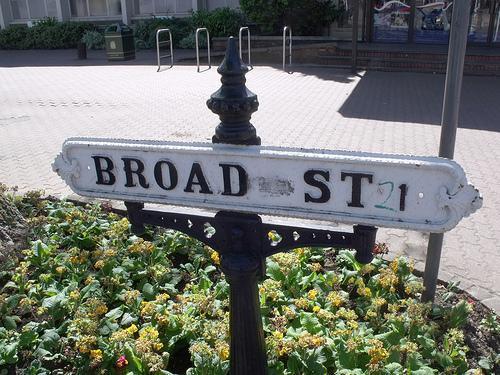How many signs are pictured?
Give a very brief answer. 1. How many vowels are on the sign?
Give a very brief answer. 2. 